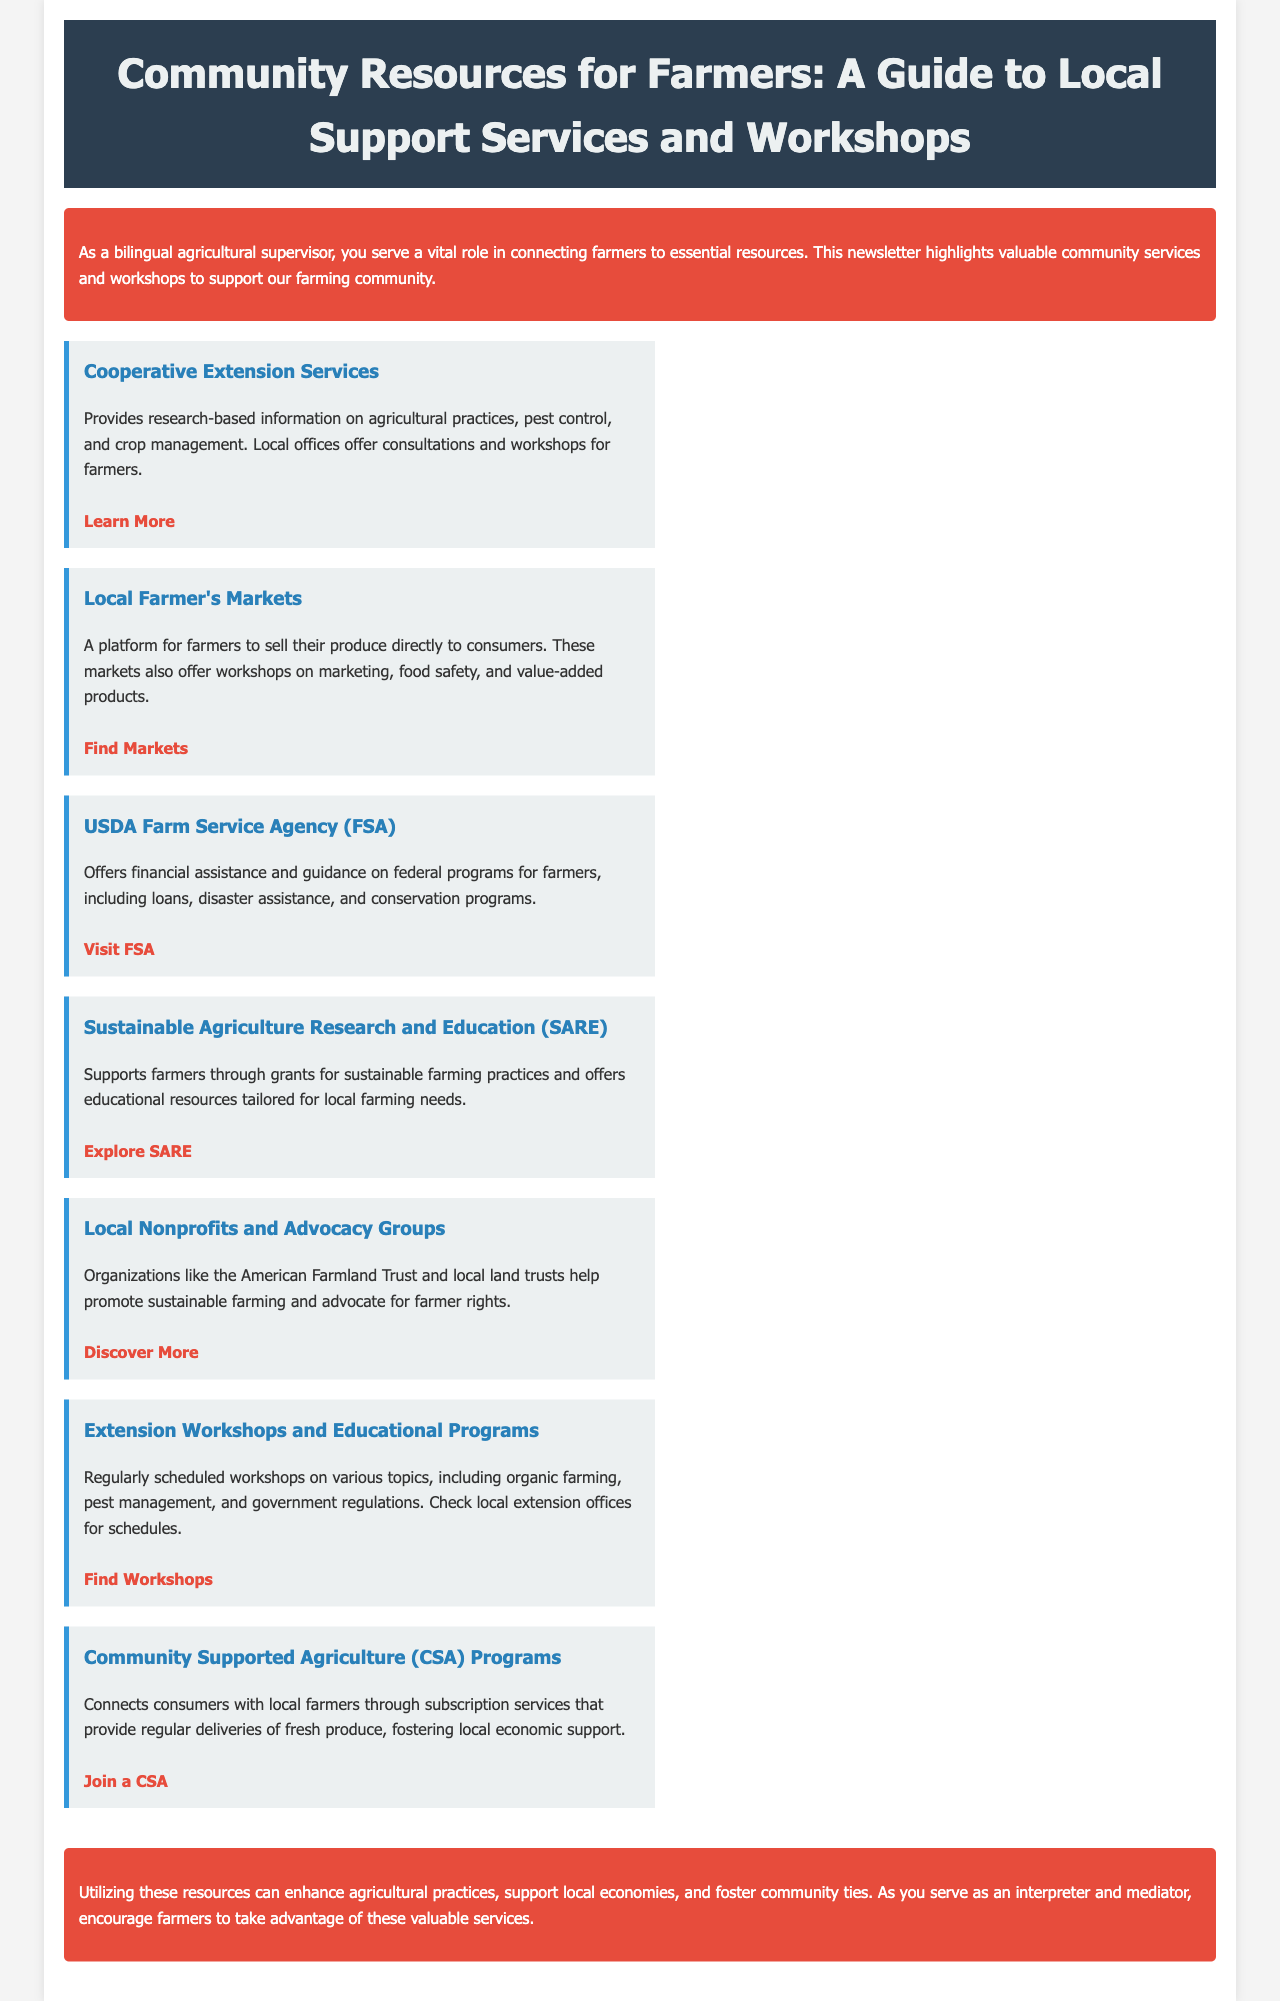What is the title of the document? The title serves as the main heading and clearly states the subject of the document.
Answer: Community Resources for Farmers: A Guide to Local Support Services and Workshops What type of services does Cooperative Extension Services provide? This refers to the specific information about the services offered in the document, particularly for Cooperative Extension Services.
Answer: Research-based information Which organization offers financial assistance to farmers? This question focuses on identifying a specific agency mentioned in the document that assists farmers financially.
Answer: USDA Farm Service Agency (FSA) What does SARE support? The question aims to identify what Sustainable Agriculture Research and Education focuses on based on the content presented.
Answer: Grants for sustainable farming practices How many resources are listed in the document? This requires counting the distinct organizations or services mentioned in the resource section of the document.
Answer: Seven What can farmers gain from participating in Local Farmer's Markets? The question asks for a summary of the benefits provided within the description of Local Farmer's Markets.
Answer: Marketing workshops What type of programs does Community Supported Agriculture (CSA) provide? This probes into the specific offerings of CSA programs, according to the provided information.
Answer: Subscription services for fresh produce What role does the bilingual agricultural supervisor play? The document explains the important function of the bilingual agricultural supervisor at the beginning.
Answer: Connecting farmers to essential resources 